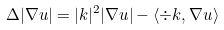Convert formula to latex. <formula><loc_0><loc_0><loc_500><loc_500>\Delta | \nabla u | = | k | ^ { 2 } | \nabla u | - \langle \div k , \nabla u \rangle</formula> 